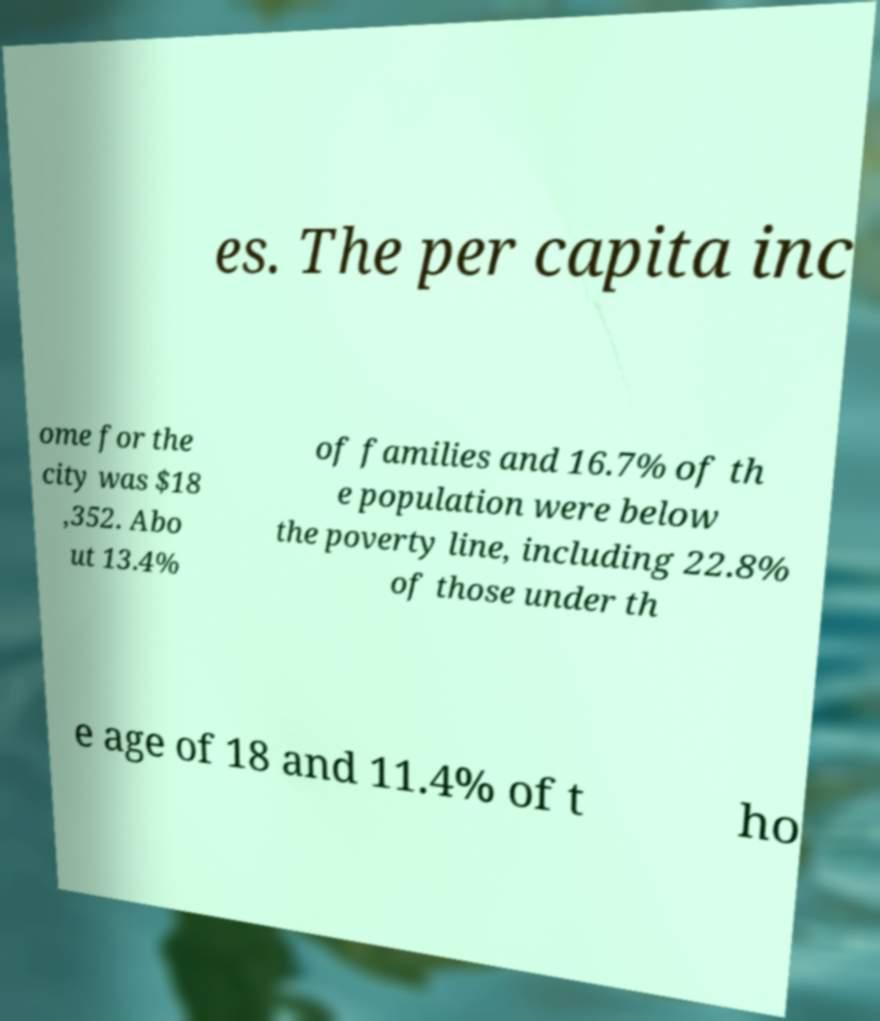What messages or text are displayed in this image? I need them in a readable, typed format. es. The per capita inc ome for the city was $18 ,352. Abo ut 13.4% of families and 16.7% of th e population were below the poverty line, including 22.8% of those under th e age of 18 and 11.4% of t ho 